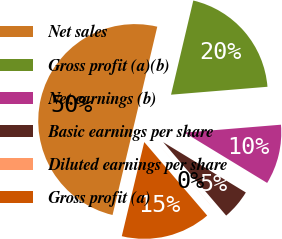<chart> <loc_0><loc_0><loc_500><loc_500><pie_chart><fcel>Net sales<fcel>Gross profit (a)(b)<fcel>Net earnings (b)<fcel>Basic earnings per share<fcel>Diluted earnings per share<fcel>Gross profit (a)<nl><fcel>49.97%<fcel>20.0%<fcel>10.01%<fcel>5.01%<fcel>0.01%<fcel>15.0%<nl></chart> 